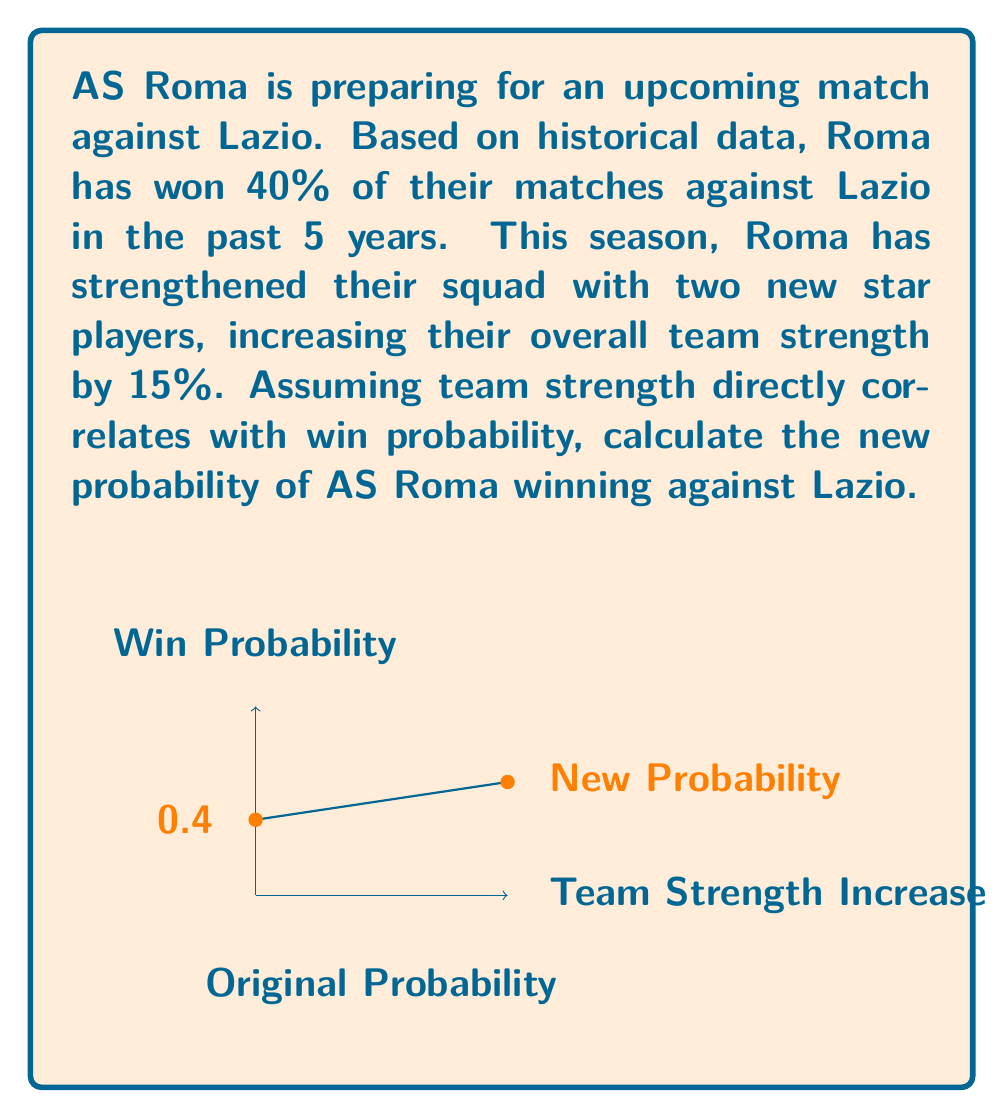Can you answer this question? Let's approach this step-by-step:

1) First, we need to understand what the given information means:
   - Historical win probability: $p = 0.40$ or 40%
   - Team strength increase: $i = 0.15$ or 15%

2) We assume that the win probability increases proportionally to the team strength increase. This means we need to calculate the increase in win probability:
   
   Increase in win probability = $p \times i = 0.40 \times 0.15 = 0.06$ or 6%

3) Now, we can calculate the new win probability by adding this increase to the original probability:

   New win probability = Original probability + Increase in probability
   $$p_{new} = p + (p \times i)$$
   $$p_{new} = 0.40 + (0.40 \times 0.15)$$
   $$p_{new} = 0.40 + 0.06 = 0.46$$

4) Convert to percentage:
   $$0.46 \times 100\% = 46\%$$

Therefore, based on the historical data and the current team composition, the new probability of AS Roma winning against Lazio is 46%.
Answer: 46% 